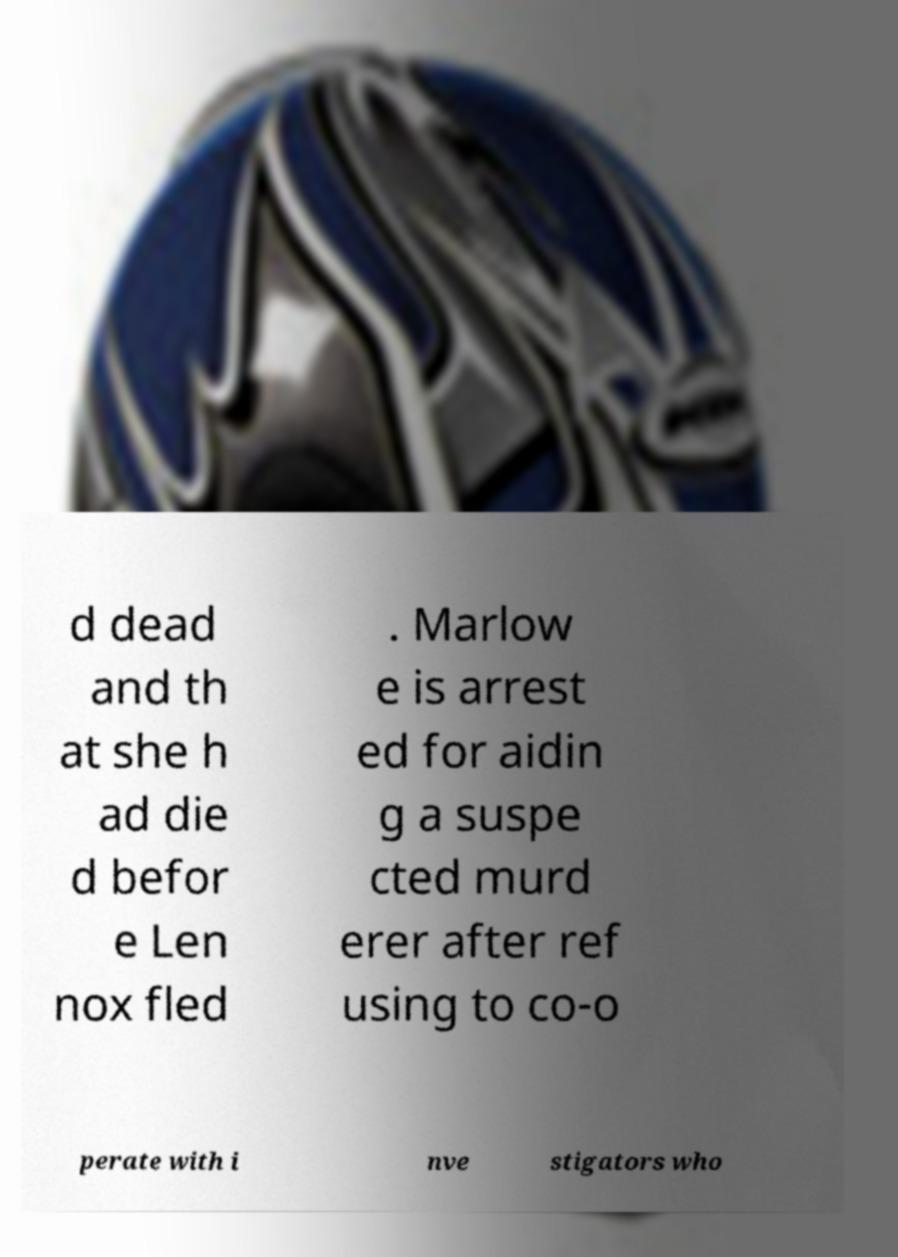There's text embedded in this image that I need extracted. Can you transcribe it verbatim? d dead and th at she h ad die d befor e Len nox fled . Marlow e is arrest ed for aidin g a suspe cted murd erer after ref using to co-o perate with i nve stigators who 